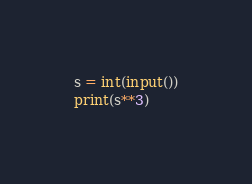<code> <loc_0><loc_0><loc_500><loc_500><_Python_>s = int(input())
print(s**3)</code> 